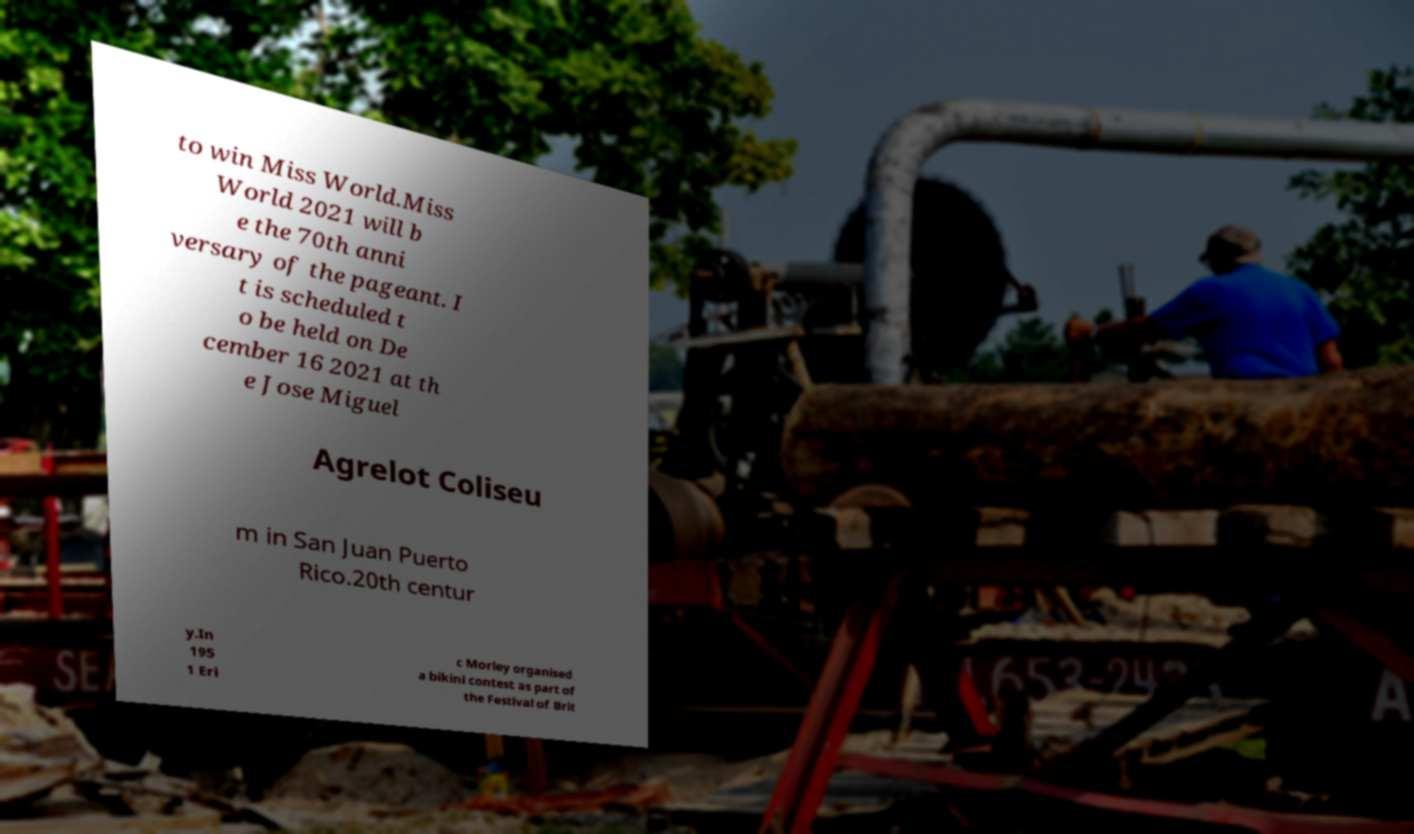Can you accurately transcribe the text from the provided image for me? to win Miss World.Miss World 2021 will b e the 70th anni versary of the pageant. I t is scheduled t o be held on De cember 16 2021 at th e Jose Miguel Agrelot Coliseu m in San Juan Puerto Rico.20th centur y.In 195 1 Eri c Morley organised a bikini contest as part of the Festival of Brit 